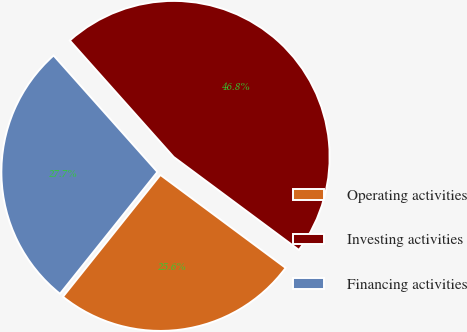<chart> <loc_0><loc_0><loc_500><loc_500><pie_chart><fcel>Operating activities<fcel>Investing activities<fcel>Financing activities<nl><fcel>25.57%<fcel>46.75%<fcel>27.68%<nl></chart> 